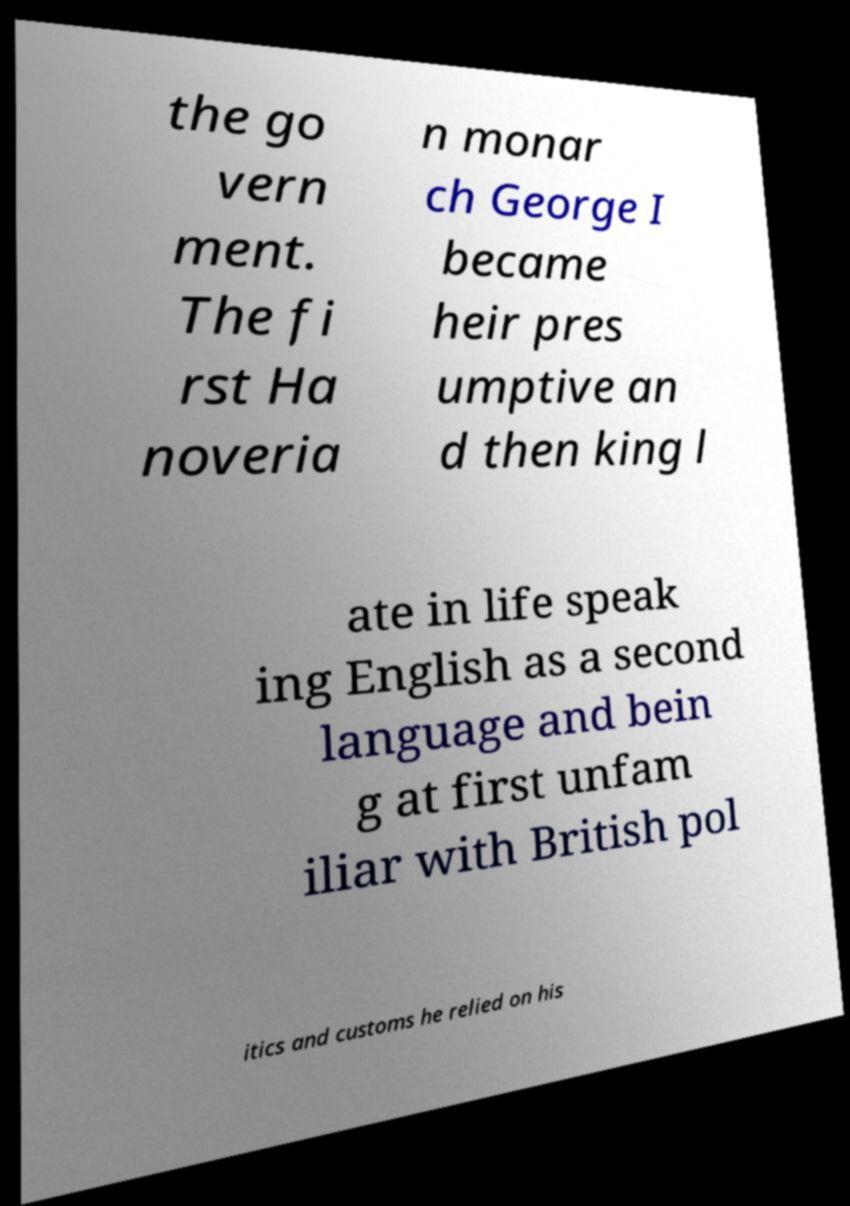What messages or text are displayed in this image? I need them in a readable, typed format. the go vern ment. The fi rst Ha noveria n monar ch George I became heir pres umptive an d then king l ate in life speak ing English as a second language and bein g at first unfam iliar with British pol itics and customs he relied on his 